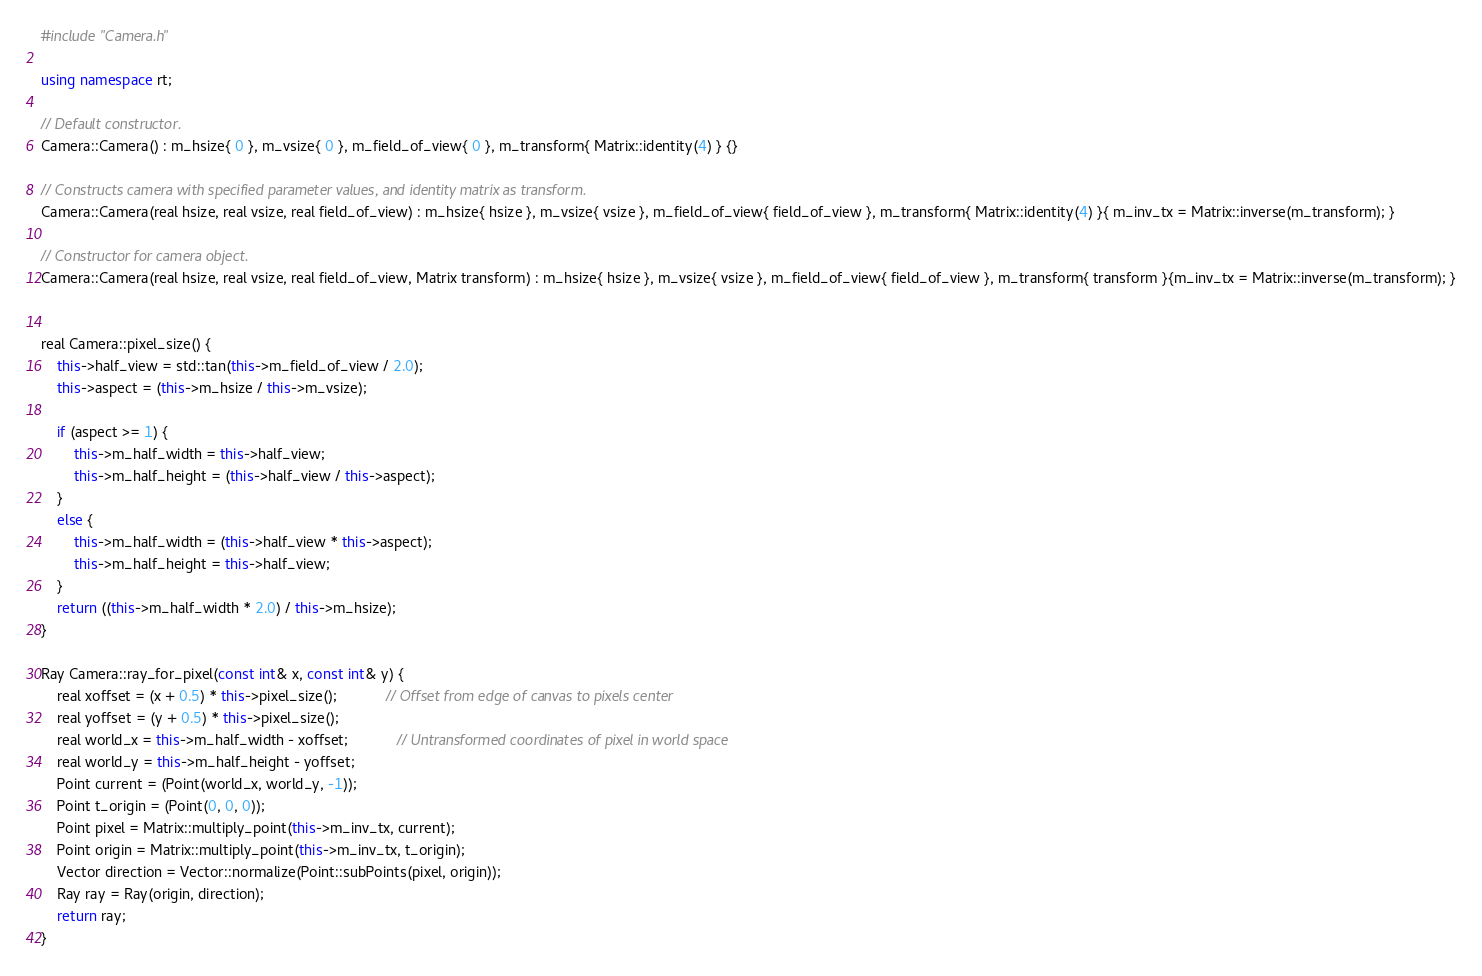<code> <loc_0><loc_0><loc_500><loc_500><_C++_>#include "Camera.h"

using namespace rt;

// Default constructor.
Camera::Camera() : m_hsize{ 0 }, m_vsize{ 0 }, m_field_of_view{ 0 }, m_transform{ Matrix::identity(4) } {}

// Constructs camera with specified parameter values, and identity matrix as transform.
Camera::Camera(real hsize, real vsize, real field_of_view) : m_hsize{ hsize }, m_vsize{ vsize }, m_field_of_view{ field_of_view }, m_transform{ Matrix::identity(4) }{ m_inv_tx = Matrix::inverse(m_transform); }

// Constructor for camera object.
Camera::Camera(real hsize, real vsize, real field_of_view, Matrix transform) : m_hsize{ hsize }, m_vsize{ vsize }, m_field_of_view{ field_of_view }, m_transform{ transform }{m_inv_tx = Matrix::inverse(m_transform); }


real Camera::pixel_size() {
	this->half_view = std::tan(this->m_field_of_view / 2.0);
	this->aspect = (this->m_hsize / this->m_vsize);

	if (aspect >= 1) {
		this->m_half_width = this->half_view;
		this->m_half_height = (this->half_view / this->aspect);
	}
	else {
		this->m_half_width = (this->half_view * this->aspect);
		this->m_half_height = this->half_view;
	}
	return ((this->m_half_width * 2.0) / this->m_hsize);
}

Ray Camera::ray_for_pixel(const int& x, const int& y) {
	real xoffset = (x + 0.5) * this->pixel_size();			// Offset from edge of canvas to pixels center
	real yoffset = (y + 0.5) * this->pixel_size();
	real world_x = this->m_half_width - xoffset;			// Untransformed coordinates of pixel in world space
	real world_y = this->m_half_height - yoffset;
	Point current = (Point(world_x, world_y, -1));
	Point t_origin = (Point(0, 0, 0));
	Point pixel = Matrix::multiply_point(this->m_inv_tx, current);
	Point origin = Matrix::multiply_point(this->m_inv_tx, t_origin);
	Vector direction = Vector::normalize(Point::subPoints(pixel, origin));
	Ray ray = Ray(origin, direction);
	return ray;
}
</code> 